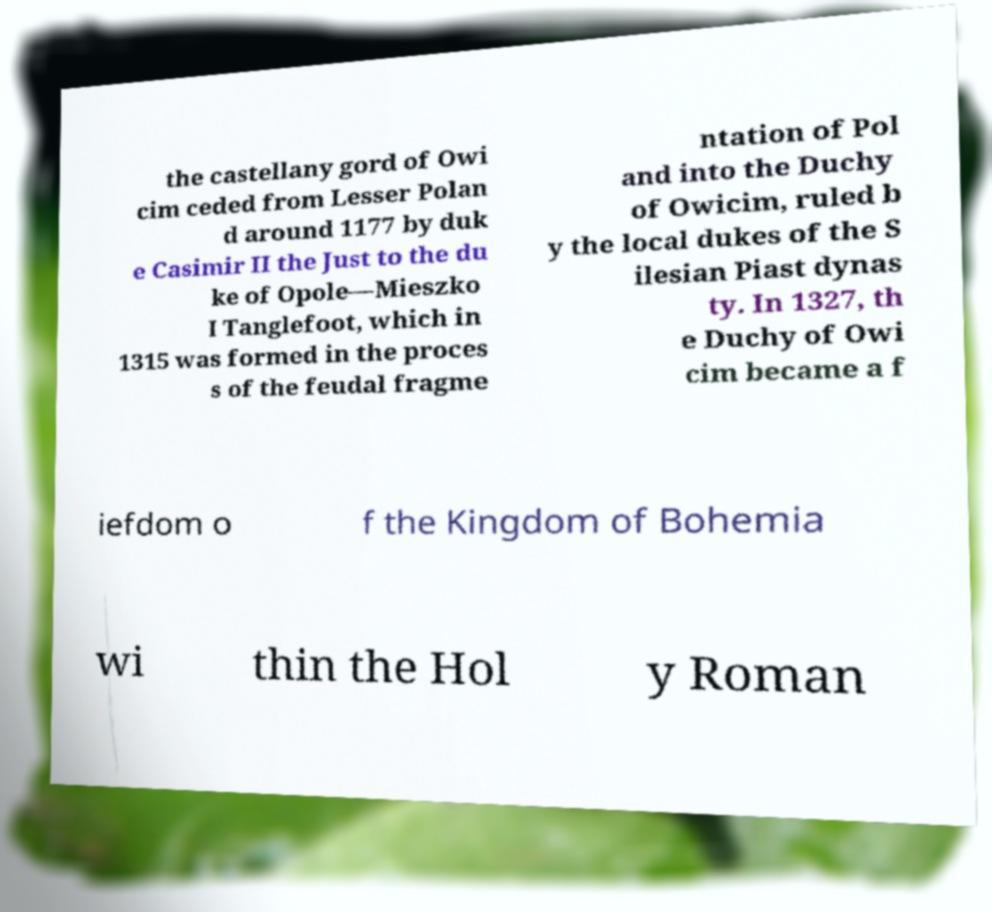I need the written content from this picture converted into text. Can you do that? the castellany gord of Owi cim ceded from Lesser Polan d around 1177 by duk e Casimir II the Just to the du ke of Opole—Mieszko I Tanglefoot, which in 1315 was formed in the proces s of the feudal fragme ntation of Pol and into the Duchy of Owicim, ruled b y the local dukes of the S ilesian Piast dynas ty. In 1327, th e Duchy of Owi cim became a f iefdom o f the Kingdom of Bohemia wi thin the Hol y Roman 